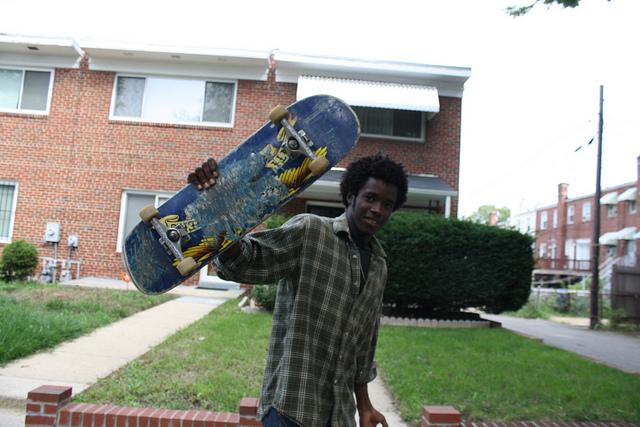Is it night time?
Answer briefly. No. Are there row houses in the background?
Short answer required. Yes. Is he holding a skateboard?
Quick response, please. Yes. 